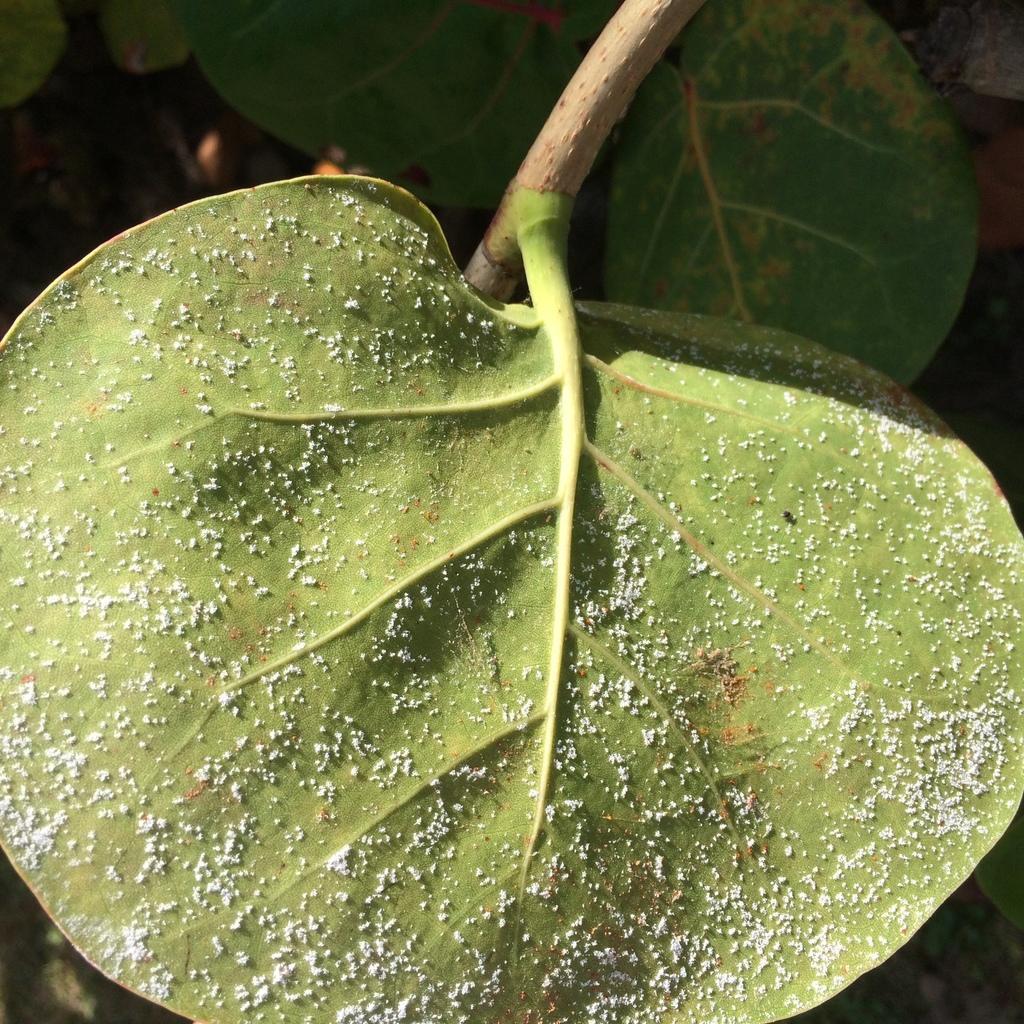Describe this image in one or two sentences. In this image, we can see some green leaves. 